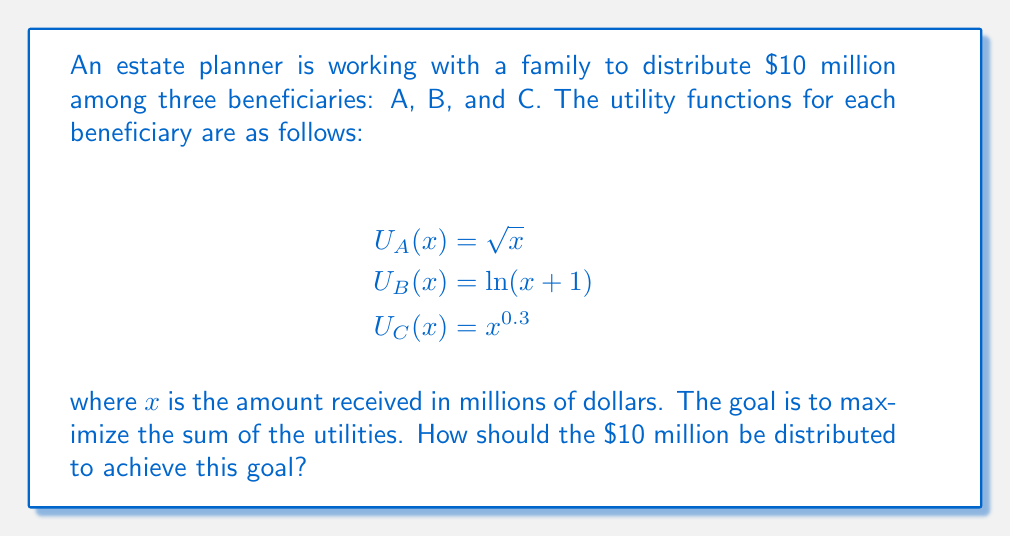Provide a solution to this math problem. To solve this problem, we need to use the concept of marginal utility and the principle that at the optimal allocation, the marginal utilities of all beneficiaries should be equal.

1) First, let's define our variables:
   Let $a$, $b$, and $c$ be the amounts allocated to A, B, and C respectively.

2) We need to maximize:
   $$U_{total} = U_A(a) + U_B(b) + U_C(c) = \sqrt{a} + \ln(b+1) + c^{0.3}$$
   Subject to the constraint: $a + b + c = 10$

3) At the optimal allocation, the marginal utilities should be equal:
   $$\frac{dU_A}{da} = \frac{dU_B}{db} = \frac{dU_C}{dc}$$

4) Let's calculate these derivatives:
   $$\frac{dU_A}{da} = \frac{1}{2\sqrt{a}}$$
   $$\frac{dU_B}{db} = \frac{1}{b+1}$$
   $$\frac{dU_C}{dc} = 0.3c^{-0.7}$$

5) Setting these equal to each other:
   $$\frac{1}{2\sqrt{a}} = \frac{1}{b+1} = 0.3c^{-0.7}$$

6) From these equations, we can derive:
   $$a = \frac{1}{4(b+1)^2}$$
   $$c = (\frac{10}{3(b+1)})^{\frac{10}{7}}$$

7) Substituting these into our constraint equation:
   $$\frac{1}{4(b+1)^2} + b + (\frac{10}{3(b+1)})^{\frac{10}{7}} = 10$$

8) This equation can be solved numerically to find $b \approx 2.718$.

9) Substituting this back, we get:
   $a \approx 4.000$
   $c \approx 3.282$

10) Rounding to two decimal places for practical distribution:
    $a = 4.00$, $b = 2.72$, $c = 3.28$
Answer: The optimal distribution is approximately:
A: $4.00 million
B: $2.72 million
C: $3.28 million 